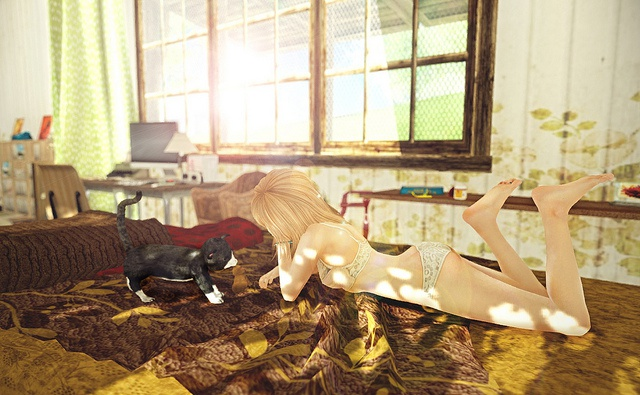Describe the objects in this image and their specific colors. I can see bed in tan, maroon, olive, and black tones, people in tan and beige tones, cat in tan, black, and gray tones, chair in tan, olive, and brown tones, and chair in tan and gray tones in this image. 